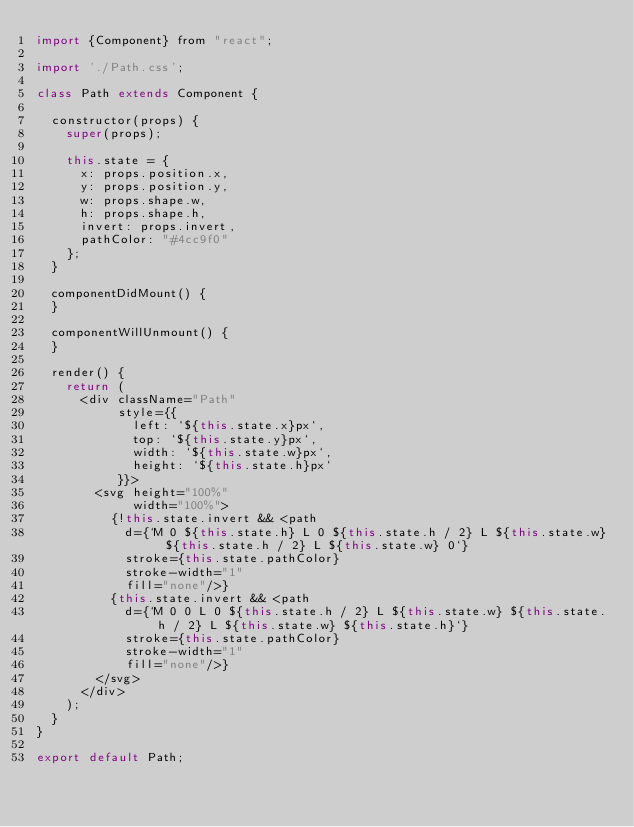Convert code to text. <code><loc_0><loc_0><loc_500><loc_500><_JavaScript_>import {Component} from "react";

import './Path.css';

class Path extends Component {

  constructor(props) {
    super(props);

    this.state = {
      x: props.position.x,
      y: props.position.y,
      w: props.shape.w,
      h: props.shape.h,
      invert: props.invert,
      pathColor: "#4cc9f0"
    };
  }

  componentDidMount() {
  }

  componentWillUnmount() {
  }

  render() {
    return (
      <div className="Path"
           style={{
             left: `${this.state.x}px`,
             top: `${this.state.y}px`,
             width: `${this.state.w}px`,
             height: `${this.state.h}px`
           }}>
        <svg height="100%"
             width="100%">
          {!this.state.invert && <path
            d={`M 0 ${this.state.h} L 0 ${this.state.h / 2} L ${this.state.w} ${this.state.h / 2} L ${this.state.w} 0`}
            stroke={this.state.pathColor}
            stroke-width="1"
            fill="none"/>}
          {this.state.invert && <path
            d={`M 0 0 L 0 ${this.state.h / 2} L ${this.state.w} ${this.state.h / 2} L ${this.state.w} ${this.state.h}`}
            stroke={this.state.pathColor}
            stroke-width="1"
            fill="none"/>}
        </svg>
      </div>
    );
  }
}

export default Path;
</code> 